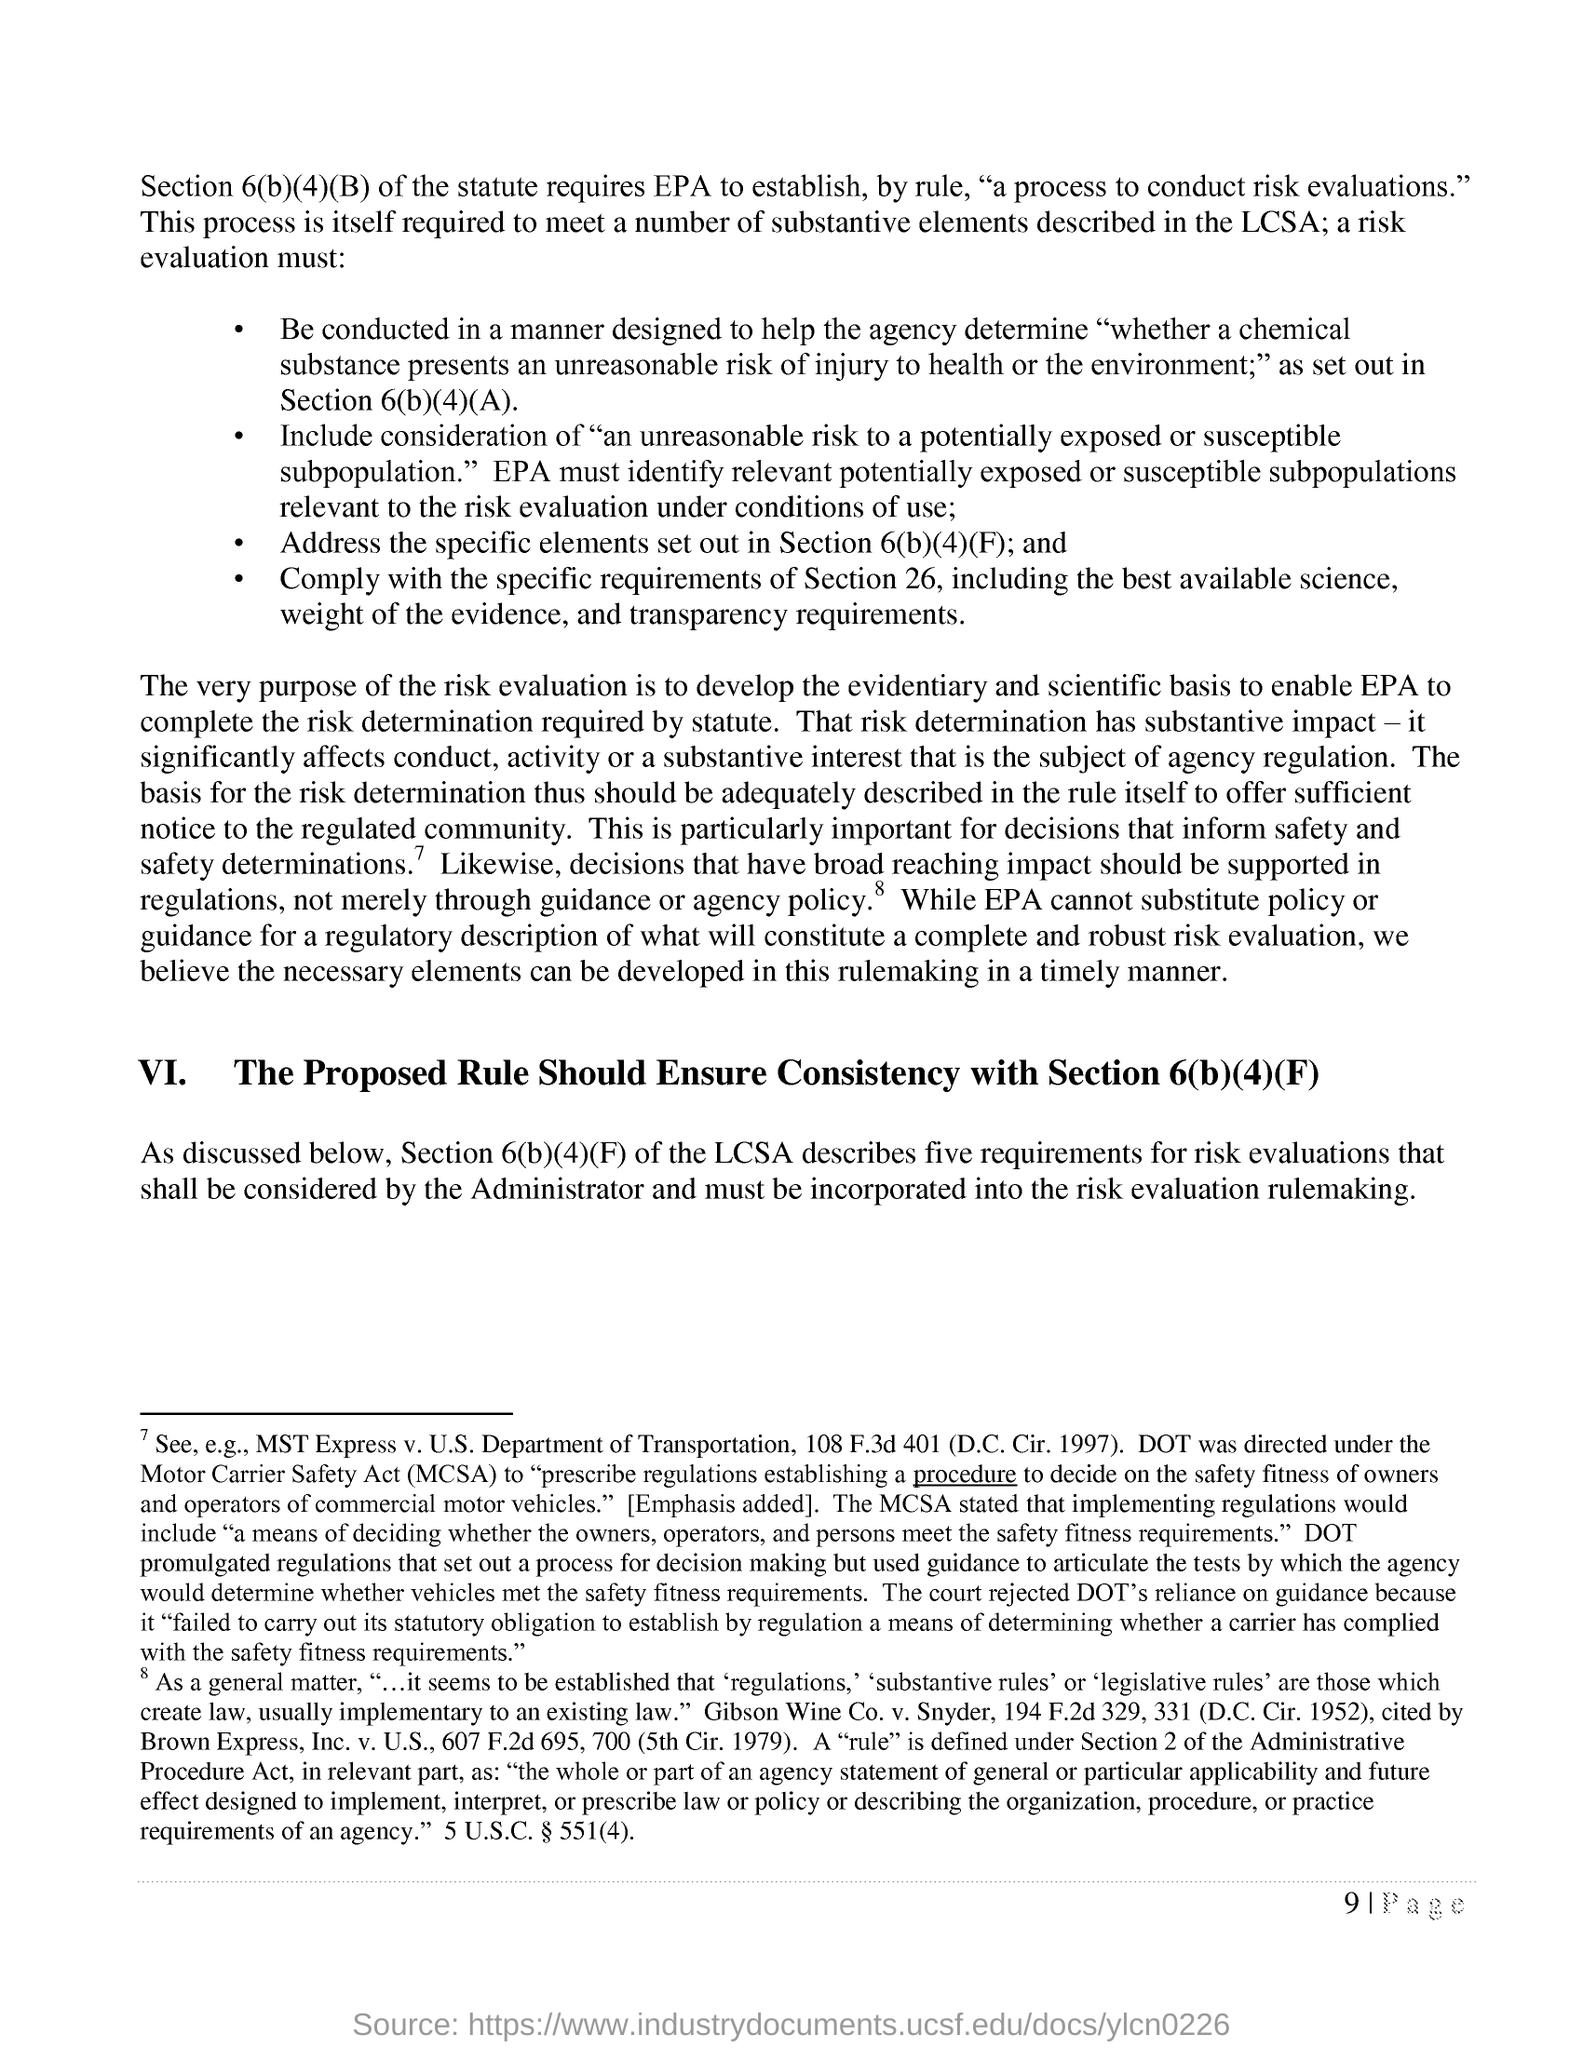What is the fullform of MCSA?
Make the answer very short. Motor Carrier Safety Act. 